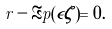<formula> <loc_0><loc_0><loc_500><loc_500>r - \Re p ( \epsilon \zeta ) = 0 .</formula> 